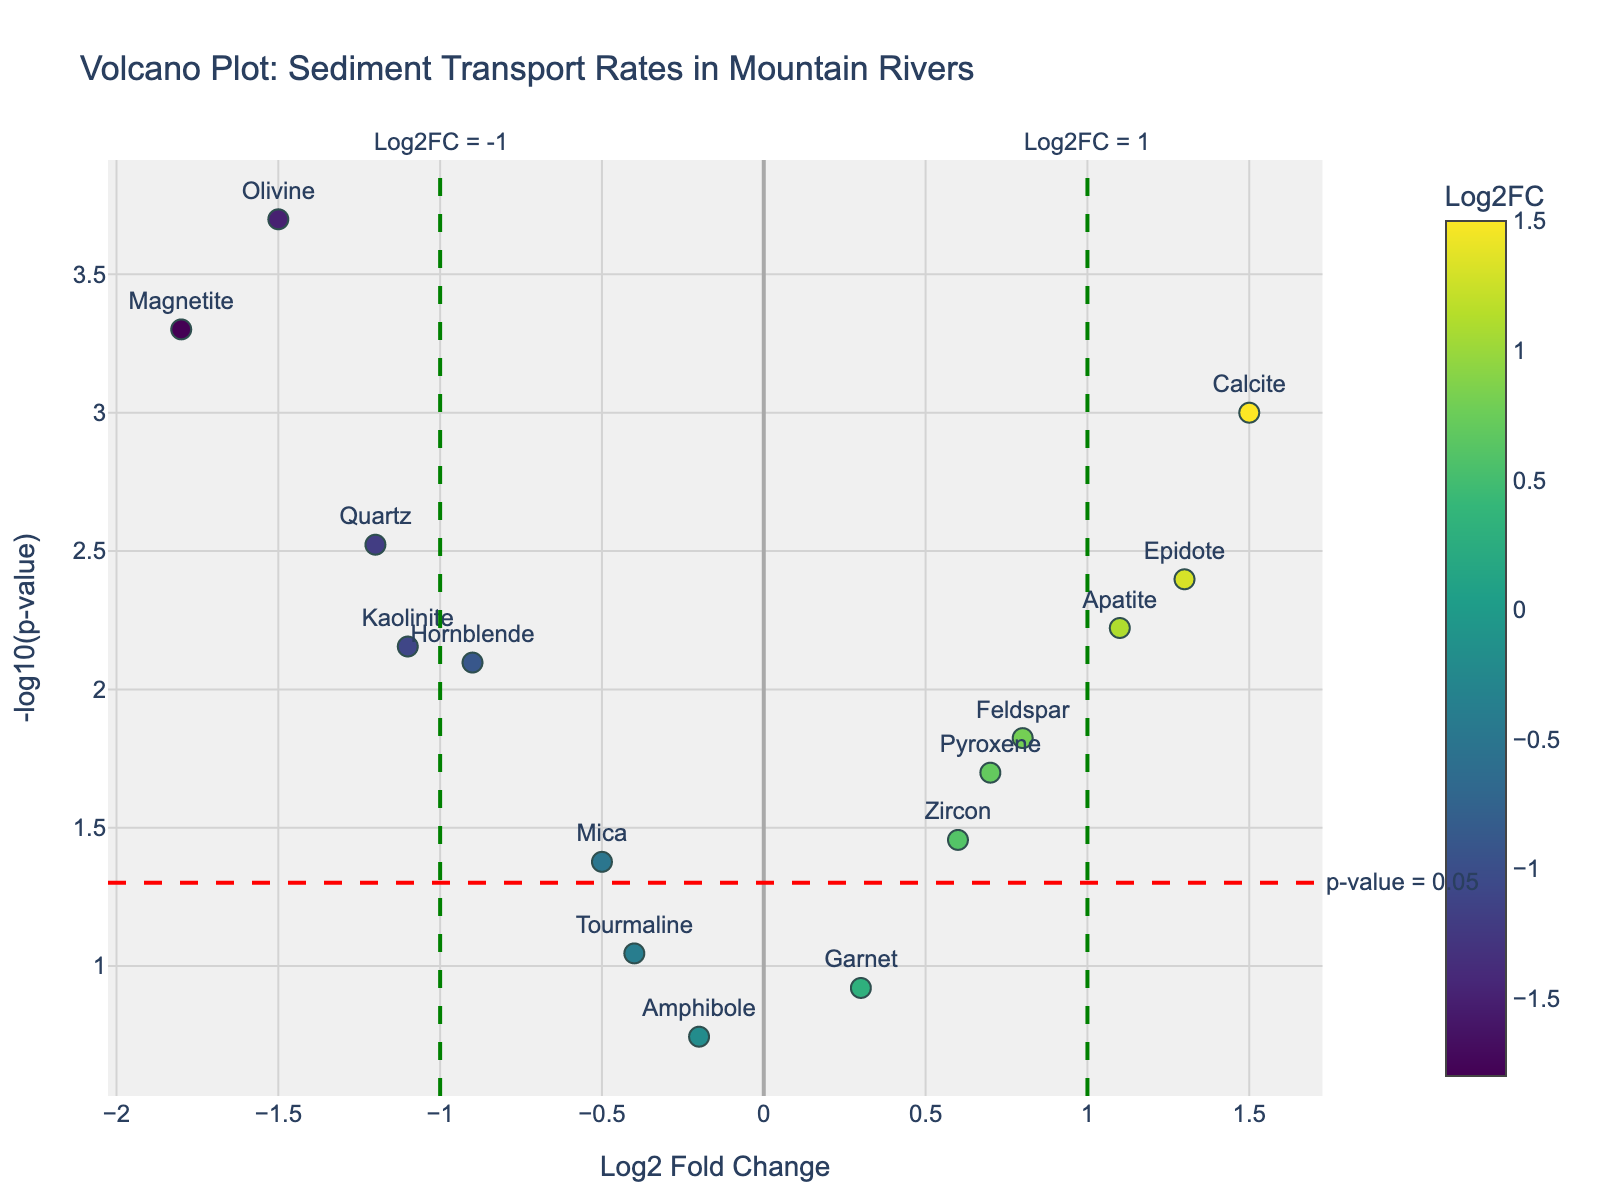What is the title of the figure? The title is typically found at the top of the plot and indicates the main topic examined in the visualization. In this case, it reads as "Volcano Plot: Sediment Transport Rates in Mountain Rivers."
Answer: Volcano Plot: Sediment Transport Rates in Mountain Rivers How many genes have significant p-values below 0.05 and Log2FC greater than 1 or less than -1? To determine this, we look for points with a p-value below 0.05 (above the red dashed horizontal line at y = 1.301) and with Log2FC greater than 1 or less than -1 (right or left of the green dashed vertical lines at x = 1 and x = -1).
Answer: 5 Which gene has the highest -log10(p-value)? Find the data point that is plotted highest on the y-axis because -log10(p-value) increases as the p-value decreases.
Answer: Magnetite Which genes have a Log2FC value between -1 and 1? Look for points that reside between the vertical lines at x = -1 and x = 1.
Answer: Mica, Garnet, Zircon, Tourmaline, Pyroxene, Amphibole What gene shows the most significant downregulation? Downregulation is indicated by negative Log2FC values. The most significant downregulation would be the lowest Log2FC with a significant p-value (below the red dashed line).
Answer: Olivine Which gene has the highest upregulation with a p-value below 0.01? Upregulation is indicated by positive Log2FC values. We look for the highest Log2FC among points below the red dashed line at y = 2.
Answer: Calcite What is the log2 fold change of Quartz? Locate the Quartz data point and check its x-axis value for Log2FC.
Answer: -1.2 How many genes exhibit upregulation (positive Log2FC) with a p-value below 0.05? Count the points to the right of x = 0 (indicating upregulation) which are above y = 1.301 (indicating below the p-value threshold).
Answer: 4 Compare the Log2FC values of Feldspar and Apatite. Which one is higher? Check the x-axis values of both Feldspar and Apatite, and see which one is further to the right.
Answer: Apatite If we only consider genes with p-values below 0.01, how many are downregulated? Focus on points above y = 2 (p-value below 0.01) and count those with negative Log2FC values (left of x = 0).
Answer: 4 